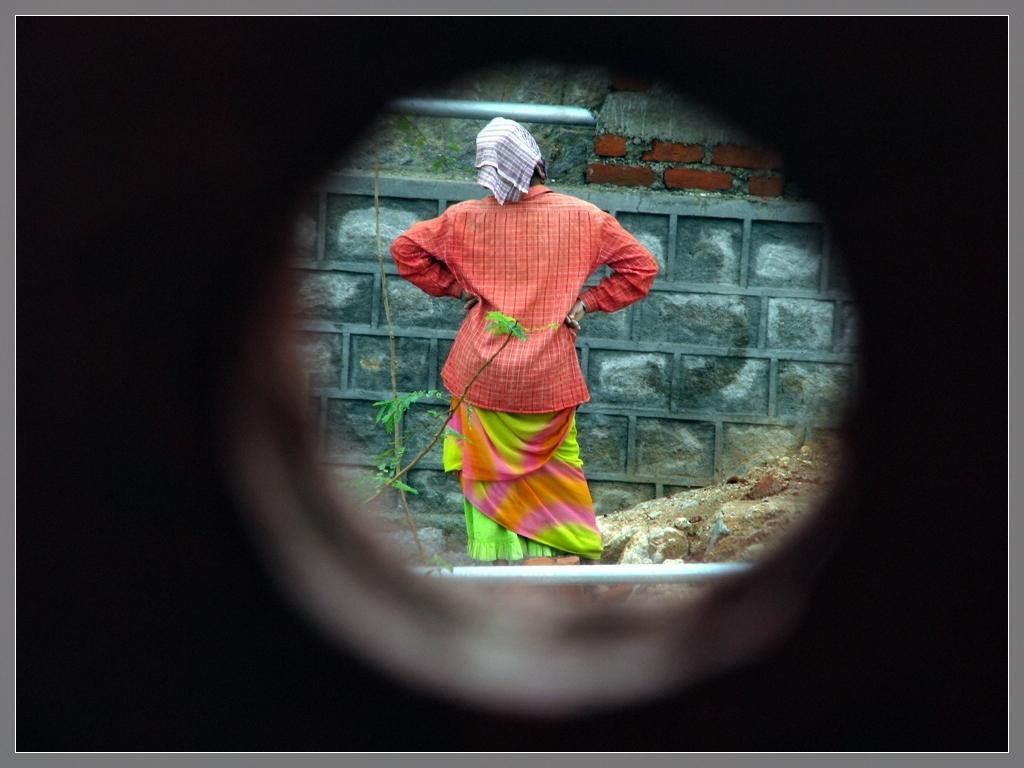What is the woman doing in the image? The woman is standing near the wall in the image. What objects can be seen in the image besides the woman? There are two poles, stones, sand, and plants in the image. Can you describe the environment in the image? The image features a combination of natural elements, such as plants, sand, and stones, as well as man-made objects like poles. What type of badge is the woman wearing in the image? There is no badge visible on the woman in the image. How does the woman lead the group of people in the image? There is no group of people present in the image, and the woman is not leading anyone. 